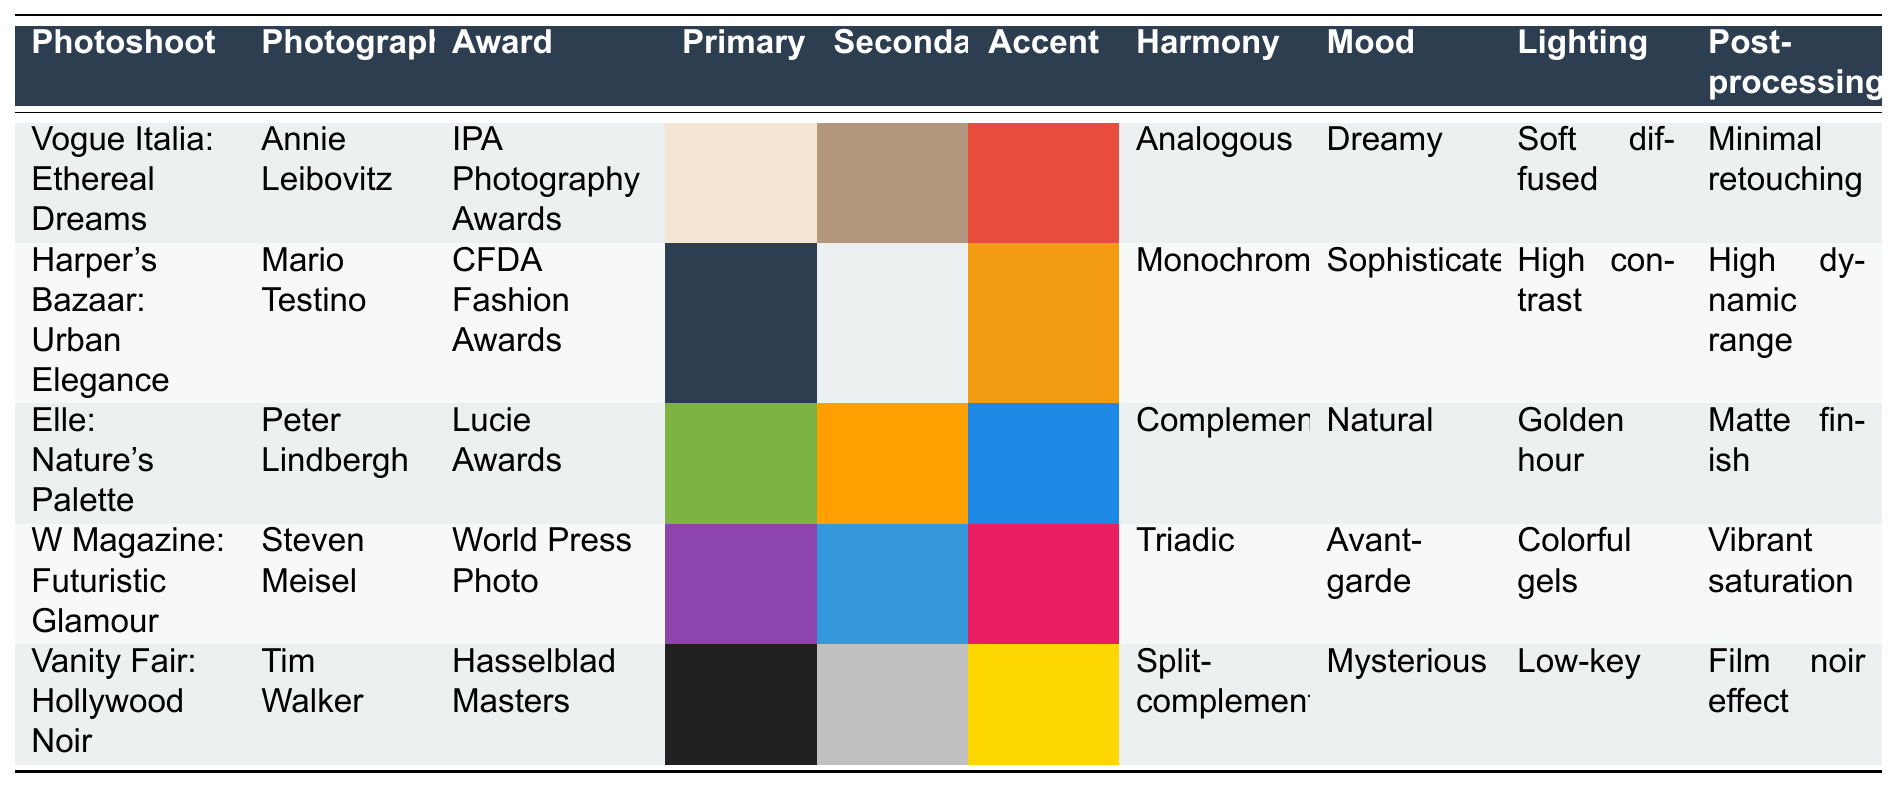What is the primary color used in "Vogue Italia: Ethereal Dreams"? The primary color for "Vogue Italia: Ethereal Dreams" is listed in the table as #F5E6D3.
Answer: #F5E6D3 Which photographer worked on the photoshoot "W Magazine: Futuristic Glamour"? The table shows that Steven Meisel is the photographer for "W Magazine: Futuristic Glamour".
Answer: Steven Meisel How many awards are represented in the table? There are five different awards listed: IPA Photography Awards, CFDA Fashion Awards, Lucie Awards, World Press Photo, and Hasselblad Masters, making a total of five.
Answer: 5 What is the accent color of "Vanity Fair: Hollywood Noir"? According to the table, the accent color of "Vanity Fair: Hollywood Noir" is #FFD700.
Answer: #FFD700 Is the color harmony of "Elle: Nature's Palette" complementary? The table indicates that "Elle: Nature's Palette" has a complementary color harmony, which means the answer is true.
Answer: True Which photoshoot evokes a dreamy mood? The table lists "Vogue Italia: Ethereal Dreams" as evoking a dreamy mood.
Answer: Vogue Italia: Ethereal Dreams How many photoshoots used a soft diffused lighting technique? Only one photoshoot, "Vogue Italia: Ethereal Dreams," has a soft diffused lighting technique.
Answer: 1 What is the difference in color harmony between "Harper's Bazaar: Urban Elegance" and "W Magazine: Futuristic Glamour"? "Harper's Bazaar: Urban Elegance" has a monochromatic harmony, while "W Magazine: Futuristic Glamour" has a triadic harmony. The difference lies in their type of color harmony.
Answer: Monochromatic vs Triadic Which mood is associated with the "Elle: Nature's Palette"? The table specifies that "Elle: Nature's Palette" is associated with a natural mood.
Answer: Natural What are the primary and secondary colors of "Harper's Bazaar: Urban Elegance"? The primary color is #2C3E50 and the secondary color is #ECF0F1, as listed in the table.
Answer: #2C3E50 and #ECF0F1 How does the lighting technique of "Vanity Fair: Hollywood Noir" differ from that of "Elle: Nature's Palette"? "Vanity Fair: Hollywood Noir" uses a low-key lighting technique, while "Elle: Nature's Palette" uses a golden hour lighting technique, indicating a difference in approach to lighting.
Answer: Low-key vs Golden hour 